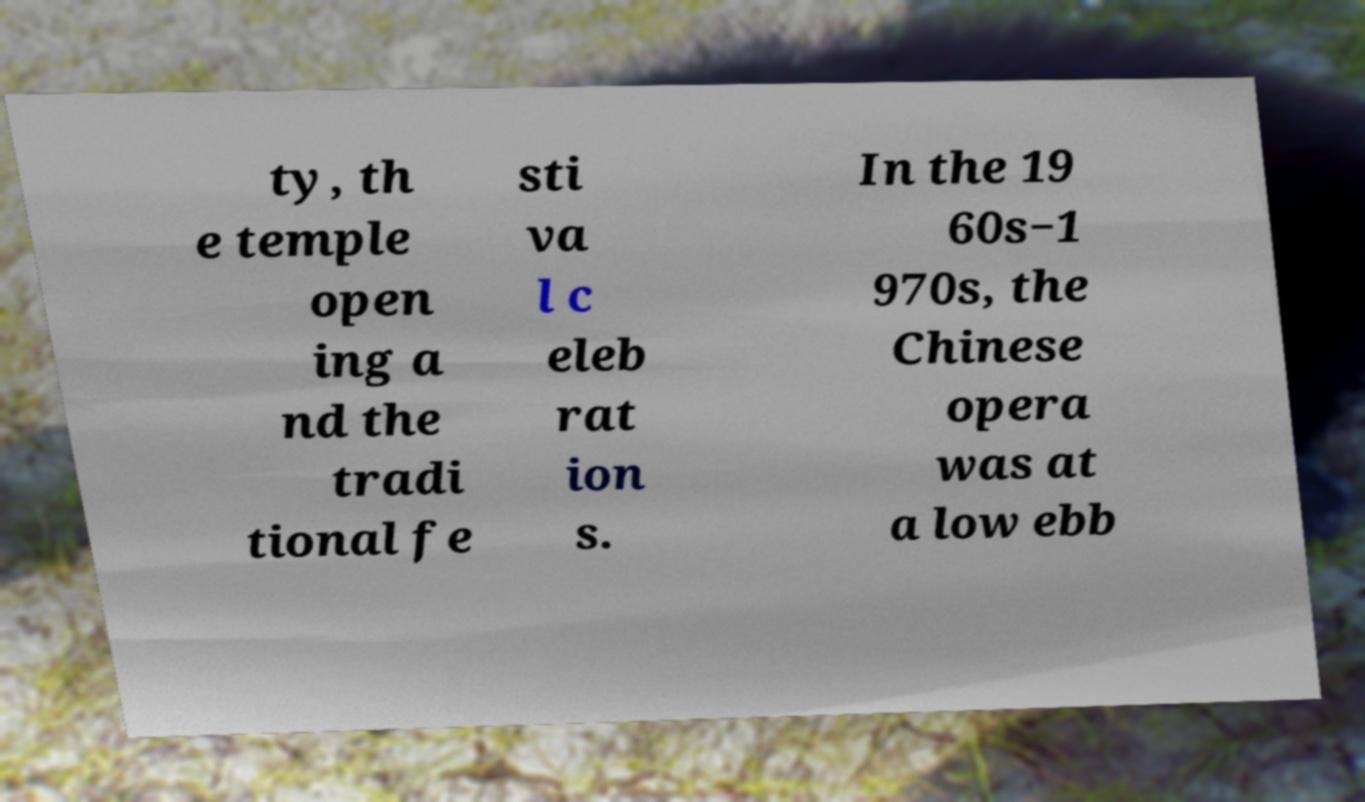There's text embedded in this image that I need extracted. Can you transcribe it verbatim? ty, th e temple open ing a nd the tradi tional fe sti va l c eleb rat ion s. In the 19 60s−1 970s, the Chinese opera was at a low ebb 